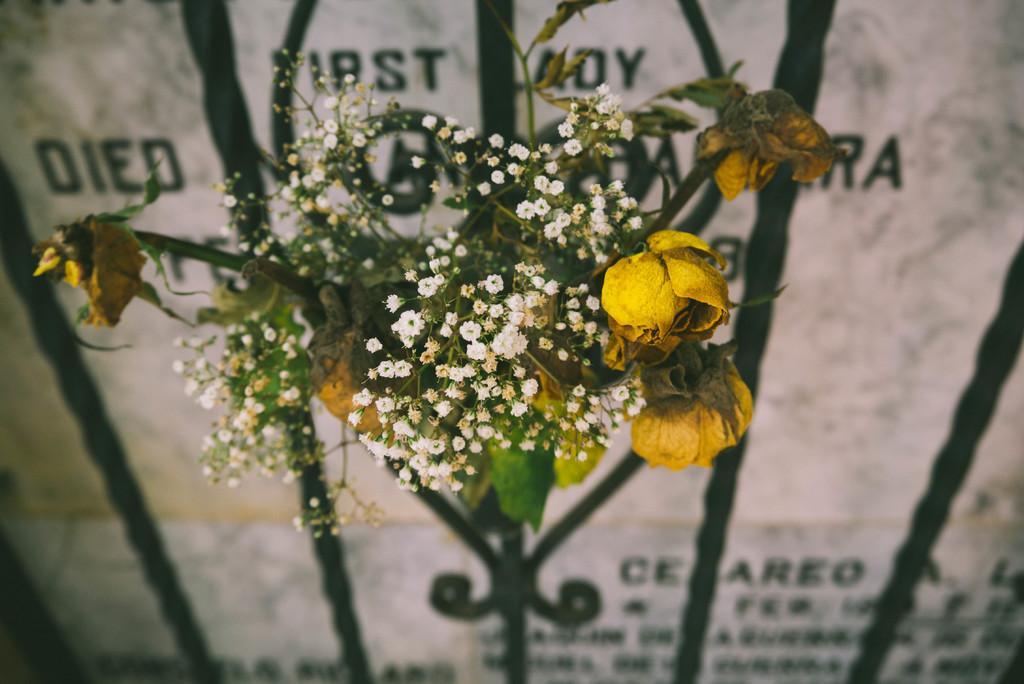Could you give a brief overview of what you see in this image? In this picture I can see there is a flower bouquet and there is a gravestone in the backdrop, there is something written on it. 